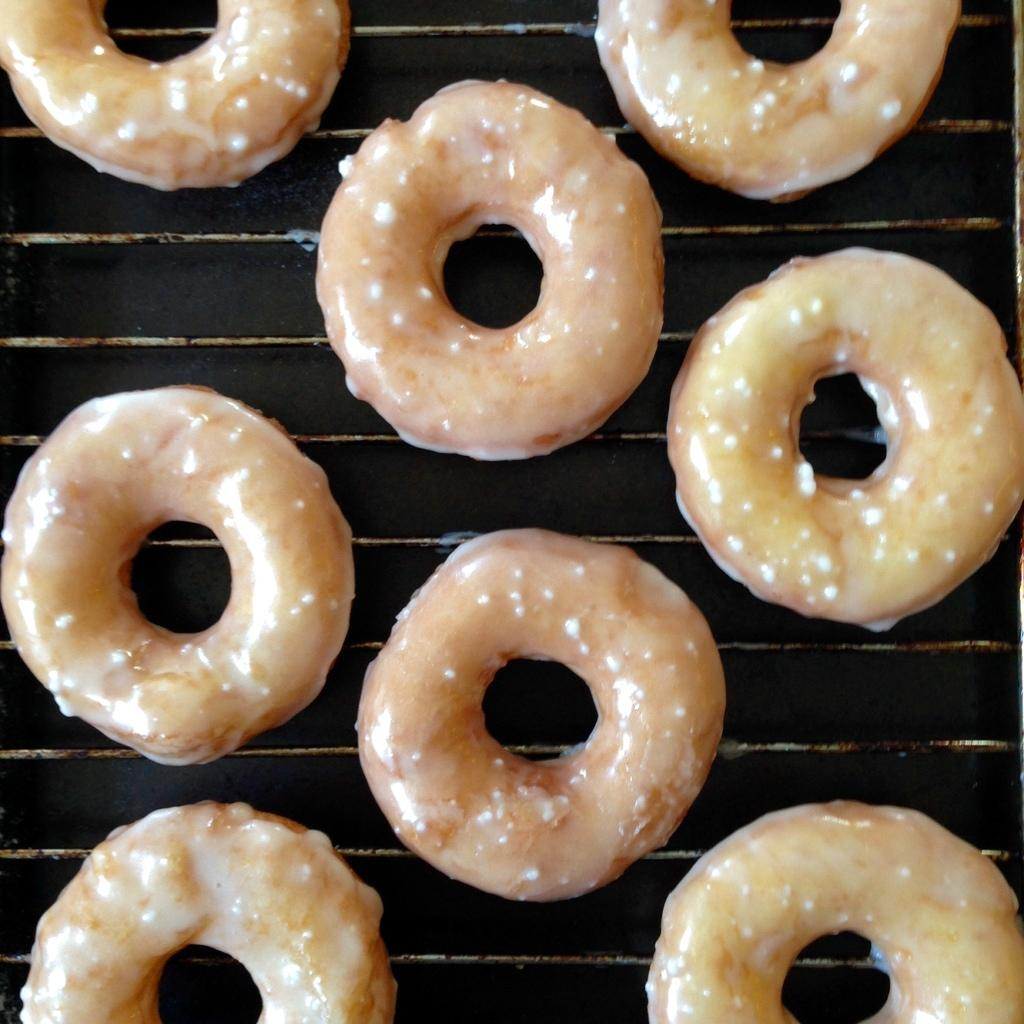What type of food can be seen in the image? There are doughnuts in the image. Where are the doughnuts located? The doughnuts are on a grill. What type of cushion is used to heat the doughnuts in the image? There is no cushion present in the image, and the doughnuts are not being heated by a cushion. 